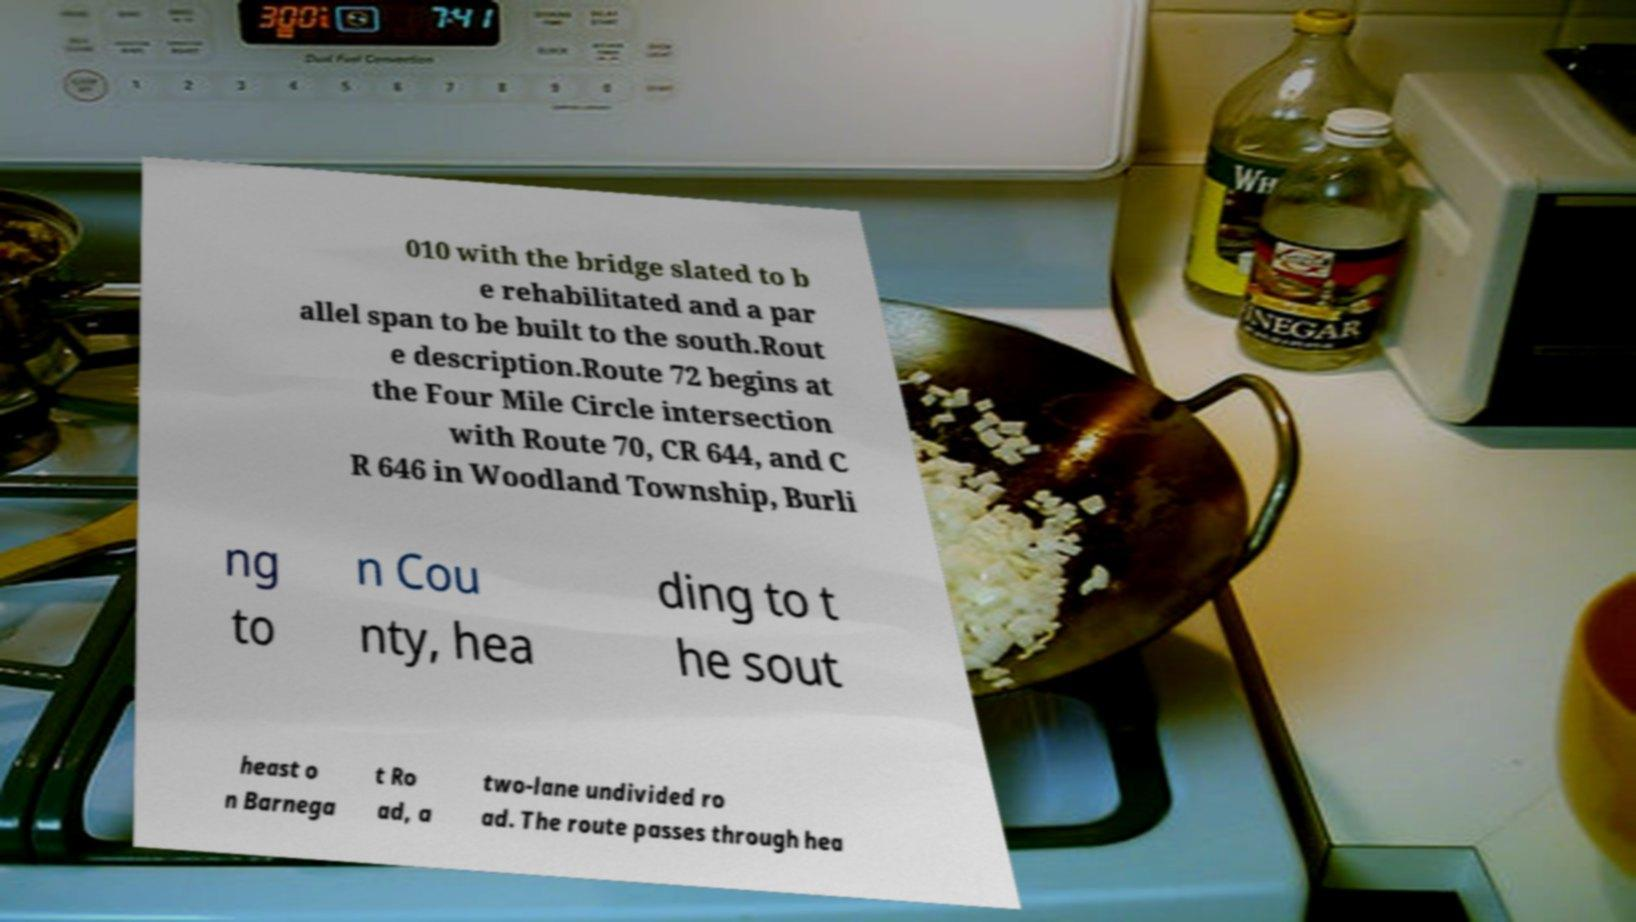What messages or text are displayed in this image? I need them in a readable, typed format. 010 with the bridge slated to b e rehabilitated and a par allel span to be built to the south.Rout e description.Route 72 begins at the Four Mile Circle intersection with Route 70, CR 644, and C R 646 in Woodland Township, Burli ng to n Cou nty, hea ding to t he sout heast o n Barnega t Ro ad, a two-lane undivided ro ad. The route passes through hea 